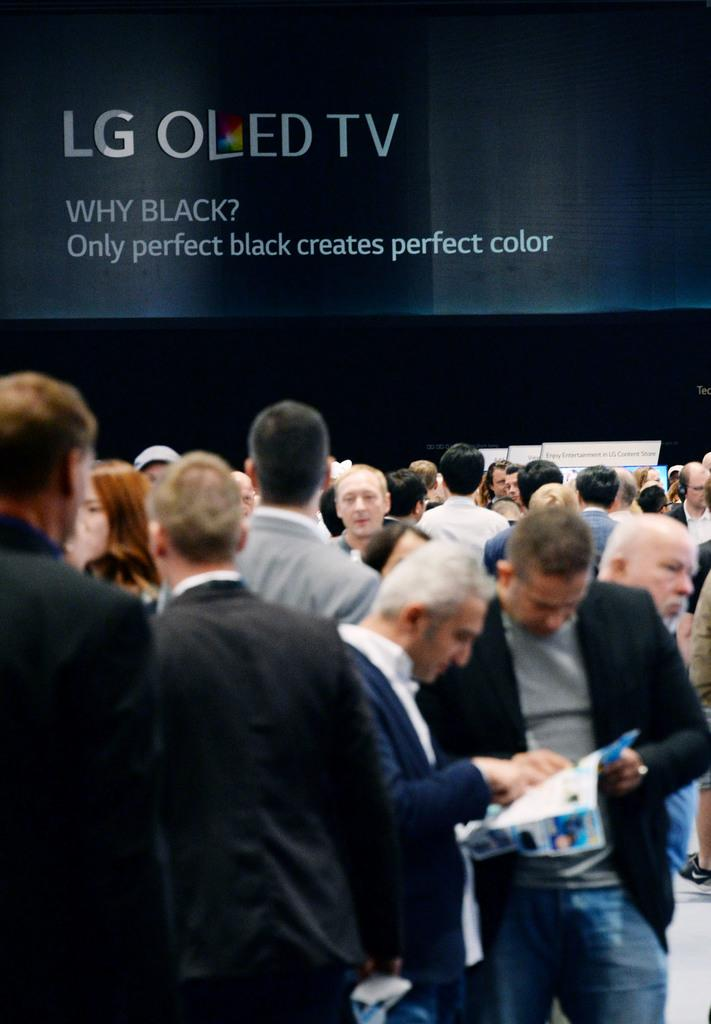What is the main subject of the image? The main subject of the image is a group of people standing in the center. What can be seen in the background of the image? There is a board in the background of the image. What is visible at the bottom right corner of the image? There is a floor visible at the bottom right corner of the image. What type of cream is being used by the people in the image? There is no cream present in the image; it features a group of people standing in the center and a board in the background. 